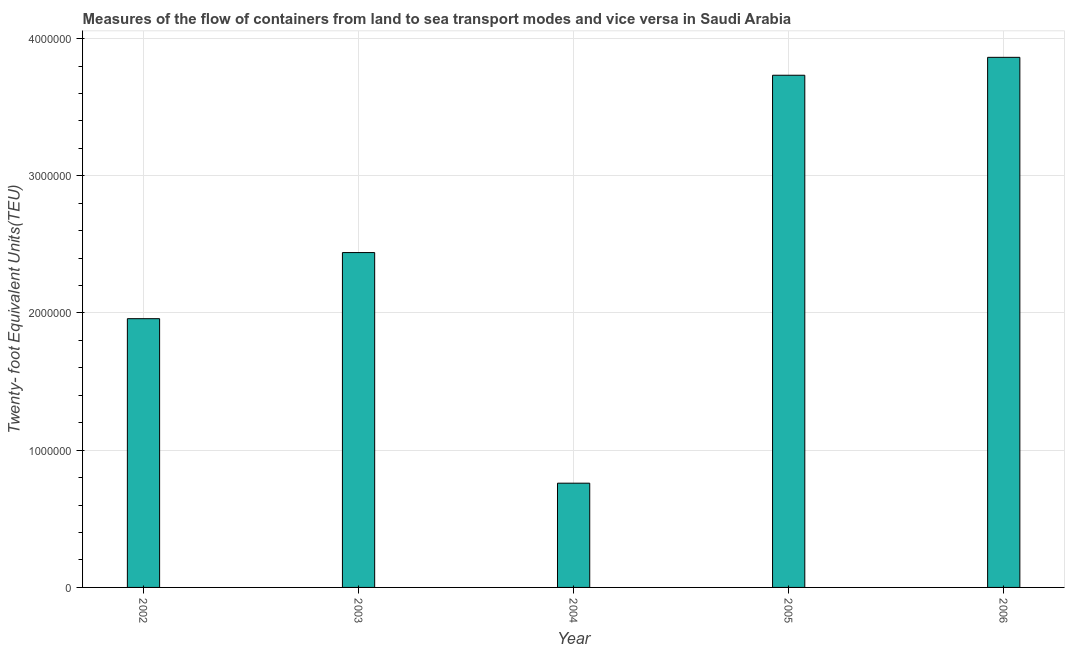What is the title of the graph?
Provide a succinct answer. Measures of the flow of containers from land to sea transport modes and vice versa in Saudi Arabia. What is the label or title of the Y-axis?
Your answer should be compact. Twenty- foot Equivalent Units(TEU). What is the container port traffic in 2006?
Give a very brief answer. 3.86e+06. Across all years, what is the maximum container port traffic?
Your answer should be very brief. 3.86e+06. Across all years, what is the minimum container port traffic?
Give a very brief answer. 7.60e+05. What is the sum of the container port traffic?
Offer a very short reply. 1.28e+07. What is the difference between the container port traffic in 2003 and 2006?
Make the answer very short. -1.42e+06. What is the average container port traffic per year?
Provide a short and direct response. 2.55e+06. What is the median container port traffic?
Offer a terse response. 2.44e+06. What is the ratio of the container port traffic in 2004 to that in 2005?
Offer a terse response. 0.2. What is the difference between the highest and the second highest container port traffic?
Make the answer very short. 1.30e+05. Is the sum of the container port traffic in 2002 and 2004 greater than the maximum container port traffic across all years?
Your answer should be very brief. No. What is the difference between the highest and the lowest container port traffic?
Offer a terse response. 3.10e+06. Are all the bars in the graph horizontal?
Offer a terse response. No. How many years are there in the graph?
Provide a succinct answer. 5. What is the difference between two consecutive major ticks on the Y-axis?
Your response must be concise. 1.00e+06. What is the Twenty- foot Equivalent Units(TEU) of 2002?
Provide a short and direct response. 1.96e+06. What is the Twenty- foot Equivalent Units(TEU) in 2003?
Provide a short and direct response. 2.44e+06. What is the Twenty- foot Equivalent Units(TEU) of 2004?
Your answer should be very brief. 7.60e+05. What is the Twenty- foot Equivalent Units(TEU) of 2005?
Make the answer very short. 3.73e+06. What is the Twenty- foot Equivalent Units(TEU) in 2006?
Keep it short and to the point. 3.86e+06. What is the difference between the Twenty- foot Equivalent Units(TEU) in 2002 and 2003?
Your answer should be very brief. -4.82e+05. What is the difference between the Twenty- foot Equivalent Units(TEU) in 2002 and 2004?
Your answer should be compact. 1.20e+06. What is the difference between the Twenty- foot Equivalent Units(TEU) in 2002 and 2005?
Make the answer very short. -1.77e+06. What is the difference between the Twenty- foot Equivalent Units(TEU) in 2002 and 2006?
Ensure brevity in your answer.  -1.90e+06. What is the difference between the Twenty- foot Equivalent Units(TEU) in 2003 and 2004?
Provide a short and direct response. 1.68e+06. What is the difference between the Twenty- foot Equivalent Units(TEU) in 2003 and 2005?
Your response must be concise. -1.29e+06. What is the difference between the Twenty- foot Equivalent Units(TEU) in 2003 and 2006?
Your response must be concise. -1.42e+06. What is the difference between the Twenty- foot Equivalent Units(TEU) in 2004 and 2005?
Make the answer very short. -2.97e+06. What is the difference between the Twenty- foot Equivalent Units(TEU) in 2004 and 2006?
Keep it short and to the point. -3.10e+06. What is the difference between the Twenty- foot Equivalent Units(TEU) in 2005 and 2006?
Make the answer very short. -1.30e+05. What is the ratio of the Twenty- foot Equivalent Units(TEU) in 2002 to that in 2003?
Your answer should be very brief. 0.8. What is the ratio of the Twenty- foot Equivalent Units(TEU) in 2002 to that in 2004?
Offer a very short reply. 2.58. What is the ratio of the Twenty- foot Equivalent Units(TEU) in 2002 to that in 2005?
Provide a short and direct response. 0.53. What is the ratio of the Twenty- foot Equivalent Units(TEU) in 2002 to that in 2006?
Give a very brief answer. 0.51. What is the ratio of the Twenty- foot Equivalent Units(TEU) in 2003 to that in 2004?
Your answer should be very brief. 3.21. What is the ratio of the Twenty- foot Equivalent Units(TEU) in 2003 to that in 2005?
Offer a terse response. 0.65. What is the ratio of the Twenty- foot Equivalent Units(TEU) in 2003 to that in 2006?
Provide a short and direct response. 0.63. What is the ratio of the Twenty- foot Equivalent Units(TEU) in 2004 to that in 2005?
Provide a succinct answer. 0.2. What is the ratio of the Twenty- foot Equivalent Units(TEU) in 2004 to that in 2006?
Your response must be concise. 0.2. What is the ratio of the Twenty- foot Equivalent Units(TEU) in 2005 to that in 2006?
Offer a very short reply. 0.97. 